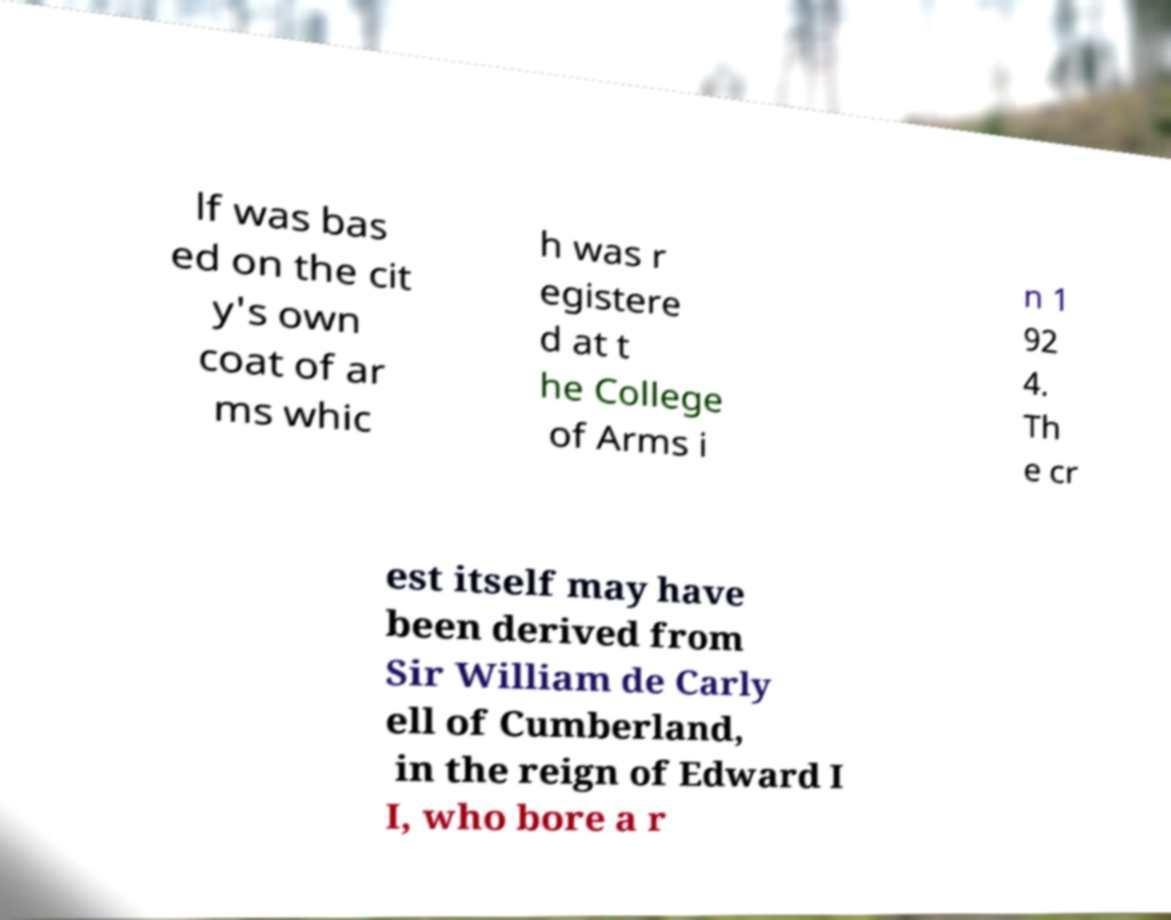Please identify and transcribe the text found in this image. lf was bas ed on the cit y's own coat of ar ms whic h was r egistere d at t he College of Arms i n 1 92 4. Th e cr est itself may have been derived from Sir William de Carly ell of Cumberland, in the reign of Edward I I, who bore a r 